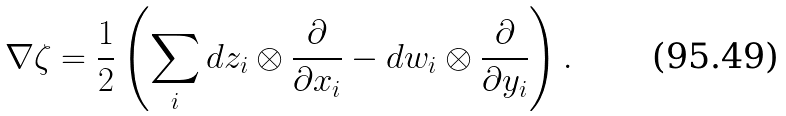<formula> <loc_0><loc_0><loc_500><loc_500>\nabla \zeta = \frac { 1 } { 2 } \left ( \sum _ { i } d z _ { i } \otimes \frac { \partial } { \partial x _ { i } } - d w _ { i } \otimes \frac { \partial } { \partial y _ { i } } \right ) .</formula> 